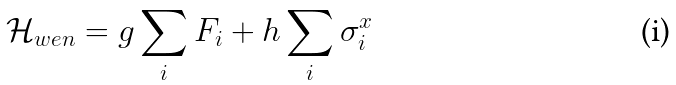Convert formula to latex. <formula><loc_0><loc_0><loc_500><loc_500>\mathcal { H } _ { w e n } = g \sum _ { i } F _ { i } + h \sum _ { i } \sigma _ { i } ^ { x }</formula> 